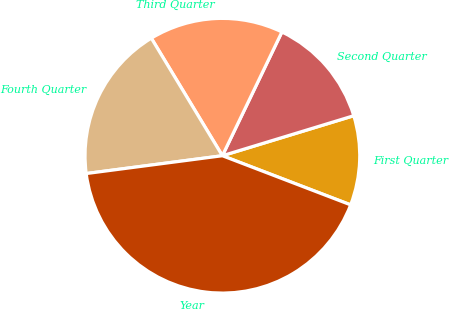<chart> <loc_0><loc_0><loc_500><loc_500><pie_chart><fcel>First Quarter<fcel>Second Quarter<fcel>Third Quarter<fcel>Fourth Quarter<fcel>Year<nl><fcel>10.53%<fcel>13.16%<fcel>15.79%<fcel>18.42%<fcel>42.11%<nl></chart> 